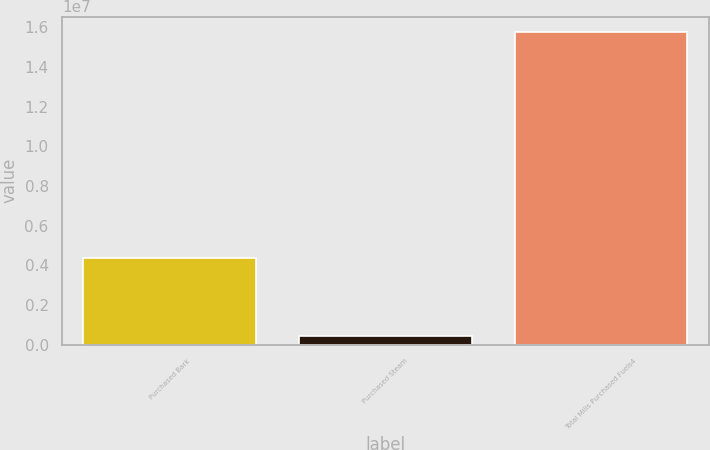Convert chart. <chart><loc_0><loc_0><loc_500><loc_500><bar_chart><fcel>Purchased Bark<fcel>Purchased Steam<fcel>Total Mills Purchased Fuels4<nl><fcel>4.38608e+06<fcel>409859<fcel>1.57622e+07<nl></chart> 